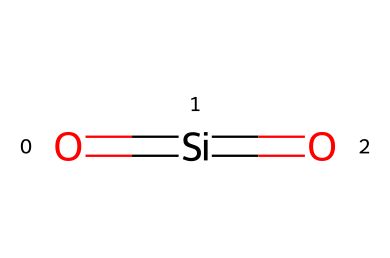What is the chemical name of the compound represented by this SMILES? The SMILES "O=[Si]=O" represents silica, specifically silicon dioxide, which is commonly known as quartz. The two oxygen atoms are bonded to the silicon atom in a double bond configuration.
Answer: silica How many oxygen atoms are present in this chemical structure? In the SMILES representation, there are two oxygen atoms indicated by the two "O" symbols. Each represents an oxygen atom directly bonded to the silicon atom.
Answer: two What type of bond is present between silicon and oxygen in this chemical? The SMILES shows "O=[Si]=O," indicating that there are double bonds between the silicon atom and each of the two oxygen atoms, which are characteristic of silicon dioxide.
Answer: double Does this compound exhibit Non-Newtonian fluid behavior? Silica can exhibit Non-Newtonian behaviors when suspended in fluids, as its particles can change the viscosity depending on stress or shear rates, but in its solid form as pure silica, it does not flow like a traditional fluid.
Answer: yes What molecular geometry is associated with the silica compound shown? The arrangement of the two double-bonded oxygen atoms around the silicon atom leads to a linear molecular geometry due to the nature of the double bonds, which creates an overall planar structure.
Answer: linear What is the primary element in this compound? The only non-hydrogen element represented in the chemical structure is silicon, which is indicated by the "Si" in the SMILES.
Answer: silicon 